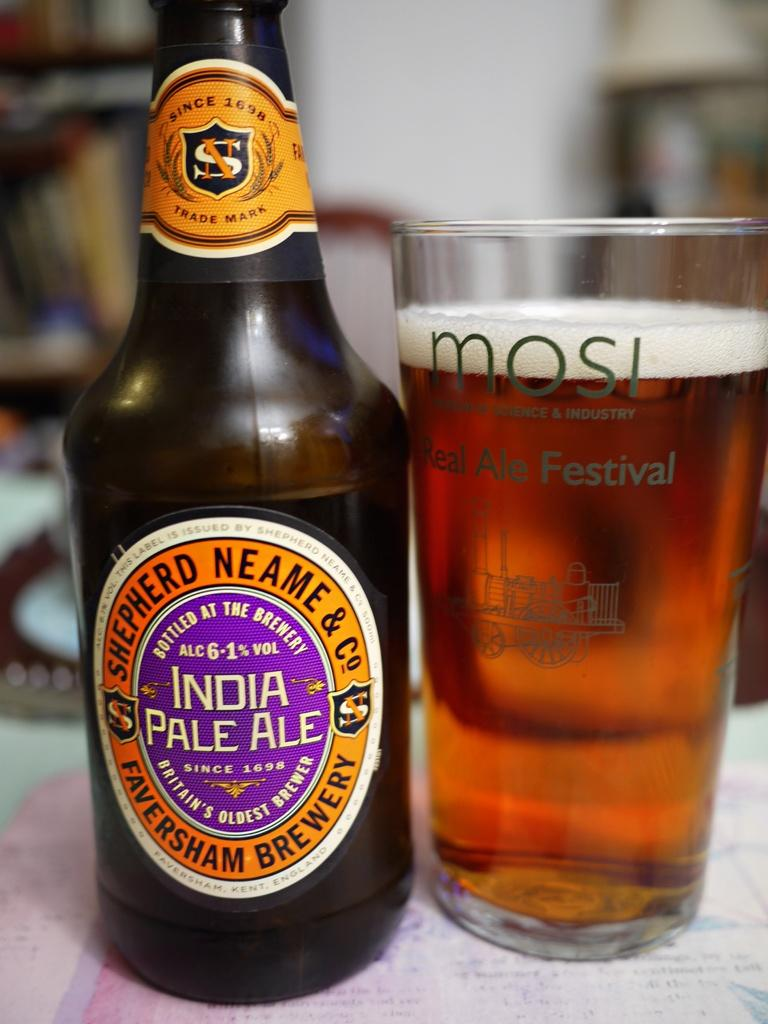<image>
Summarize the visual content of the image. India Pale ale with a glass of beer on the side of the bottle 